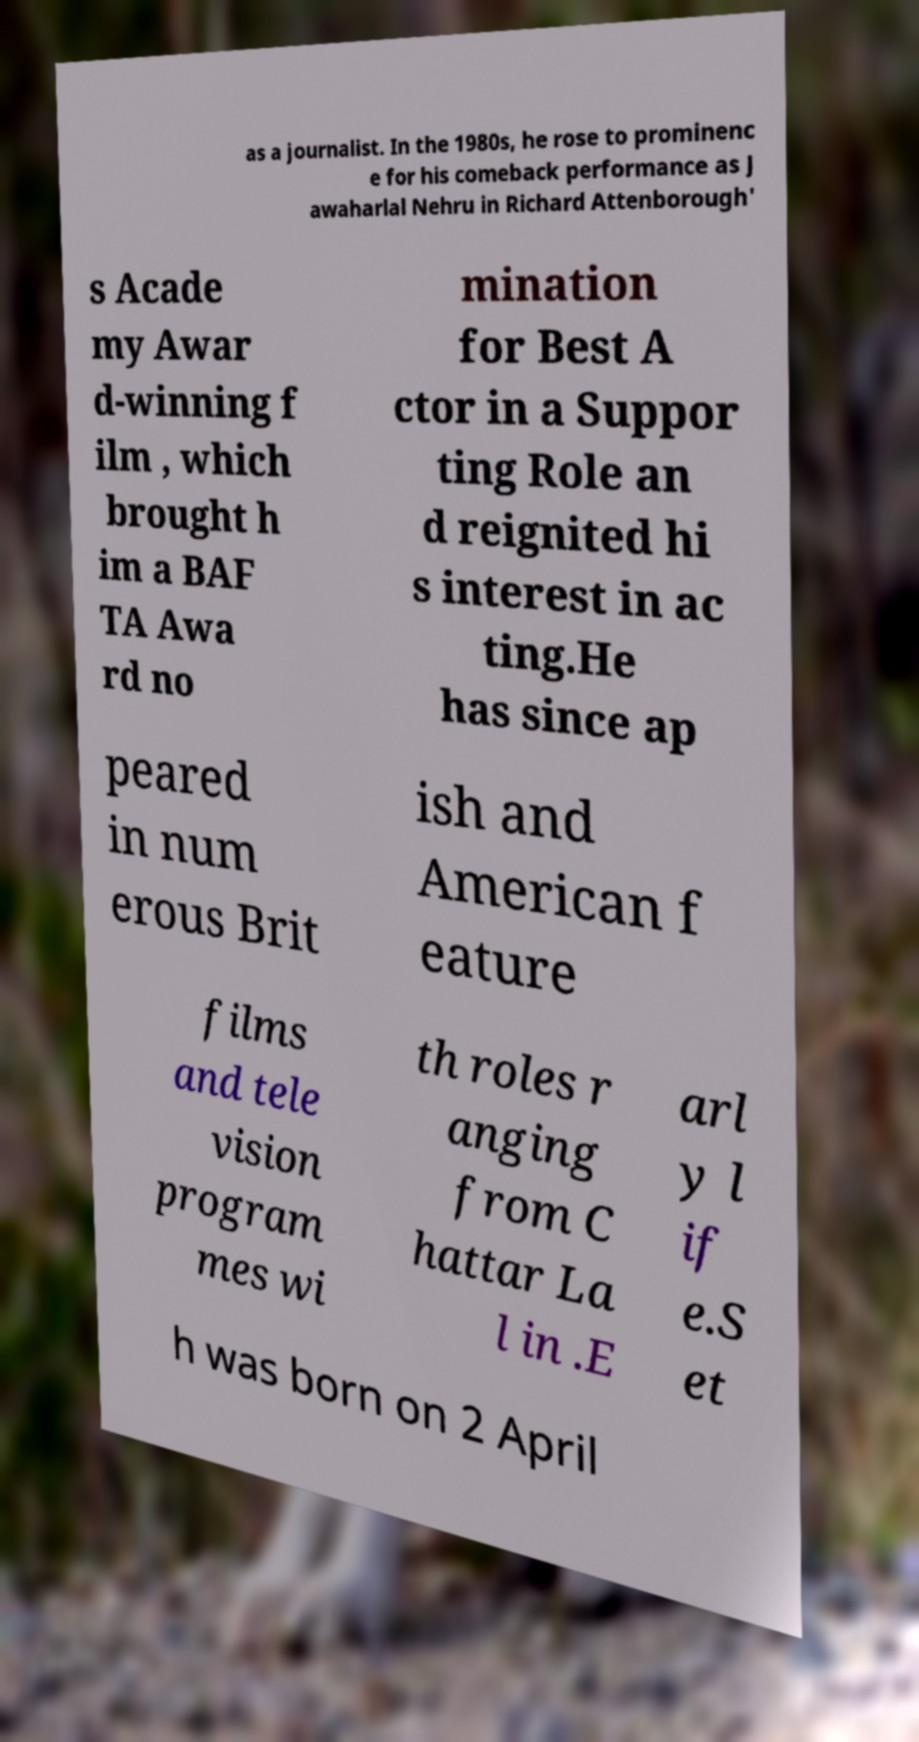What messages or text are displayed in this image? I need them in a readable, typed format. as a journalist. In the 1980s, he rose to prominenc e for his comeback performance as J awaharlal Nehru in Richard Attenborough' s Acade my Awar d-winning f ilm , which brought h im a BAF TA Awa rd no mination for Best A ctor in a Suppor ting Role an d reignited hi s interest in ac ting.He has since ap peared in num erous Brit ish and American f eature films and tele vision program mes wi th roles r anging from C hattar La l in .E arl y l if e.S et h was born on 2 April 